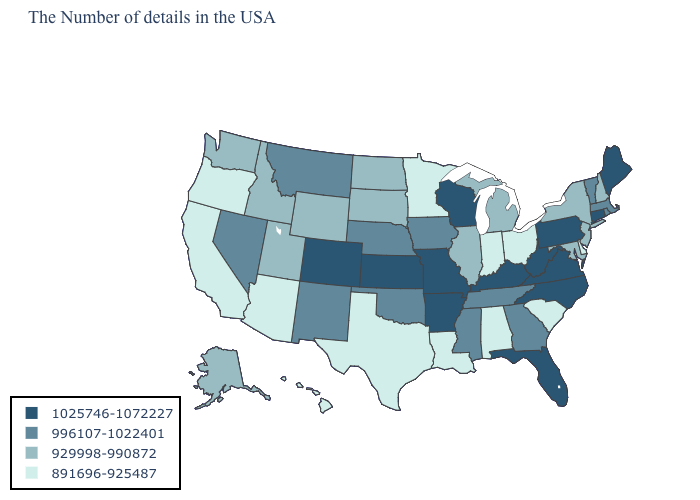Which states have the lowest value in the USA?
Write a very short answer. Delaware, South Carolina, Ohio, Indiana, Alabama, Louisiana, Minnesota, Texas, Arizona, California, Oregon, Hawaii. What is the value of North Carolina?
Write a very short answer. 1025746-1072227. Which states have the highest value in the USA?
Concise answer only. Maine, Connecticut, Pennsylvania, Virginia, North Carolina, West Virginia, Florida, Kentucky, Wisconsin, Missouri, Arkansas, Kansas, Colorado. What is the value of South Dakota?
Keep it brief. 929998-990872. Which states have the lowest value in the South?
Answer briefly. Delaware, South Carolina, Alabama, Louisiana, Texas. Among the states that border Idaho , which have the highest value?
Answer briefly. Montana, Nevada. What is the value of Arkansas?
Write a very short answer. 1025746-1072227. Which states have the lowest value in the MidWest?
Quick response, please. Ohio, Indiana, Minnesota. Does West Virginia have the same value as Ohio?
Keep it brief. No. Name the states that have a value in the range 929998-990872?
Be succinct. New Hampshire, New York, New Jersey, Maryland, Michigan, Illinois, South Dakota, North Dakota, Wyoming, Utah, Idaho, Washington, Alaska. What is the highest value in the Northeast ?
Answer briefly. 1025746-1072227. Does Kansas have the lowest value in the MidWest?
Quick response, please. No. Which states hav the highest value in the MidWest?
Quick response, please. Wisconsin, Missouri, Kansas. Name the states that have a value in the range 929998-990872?
Keep it brief. New Hampshire, New York, New Jersey, Maryland, Michigan, Illinois, South Dakota, North Dakota, Wyoming, Utah, Idaho, Washington, Alaska. What is the value of Wyoming?
Keep it brief. 929998-990872. 